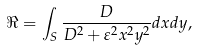Convert formula to latex. <formula><loc_0><loc_0><loc_500><loc_500>\Re = \int _ { S } { \frac { D } { { D } ^ { 2 } + { \varepsilon } ^ { 2 } x ^ { 2 } y ^ { 2 } } } d x d y ,</formula> 